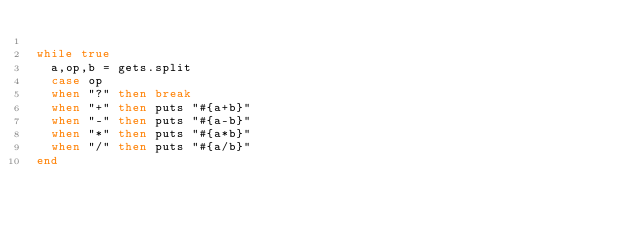Convert code to text. <code><loc_0><loc_0><loc_500><loc_500><_Ruby_>
while true
  a,op,b = gets.split
  case op
  when "?" then break
  when "+" then puts "#{a+b}"
  when "-" then puts "#{a-b}"
  when "*" then puts "#{a*b}" 
  when "/" then puts "#{a/b}" 
end</code> 